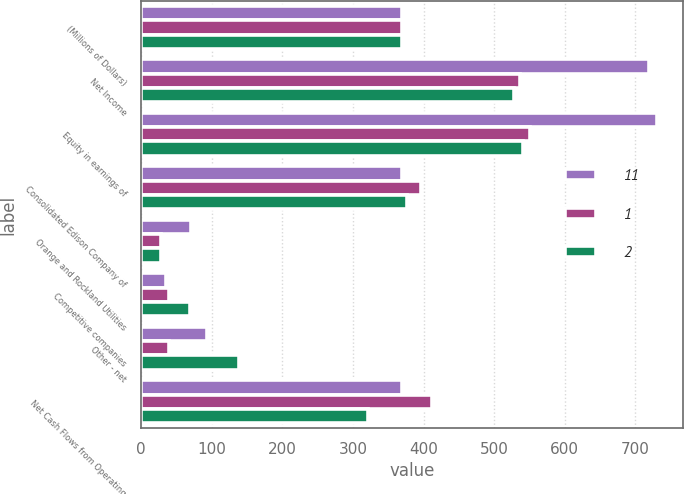Convert chart. <chart><loc_0><loc_0><loc_500><loc_500><stacked_bar_chart><ecel><fcel>(Millions of Dollars)<fcel>Net Income<fcel>Equity in earnings of<fcel>Consolidated Edison Company of<fcel>Orange and Rockland Utilities<fcel>Competitive companies<fcel>Other - net<fcel>Net Cash Flows from Operating<nl><fcel>11<fcel>369<fcel>719<fcel>731<fcel>369<fcel>71<fcel>35<fcel>94<fcel>369<nl><fcel>1<fcel>369<fcel>537<fcel>550<fcel>396<fcel>28<fcel>40<fcel>39<fcel>412<nl><fcel>2<fcel>369<fcel>528<fcel>541<fcel>376<fcel>28<fcel>69<fcel>139<fcel>321<nl></chart> 